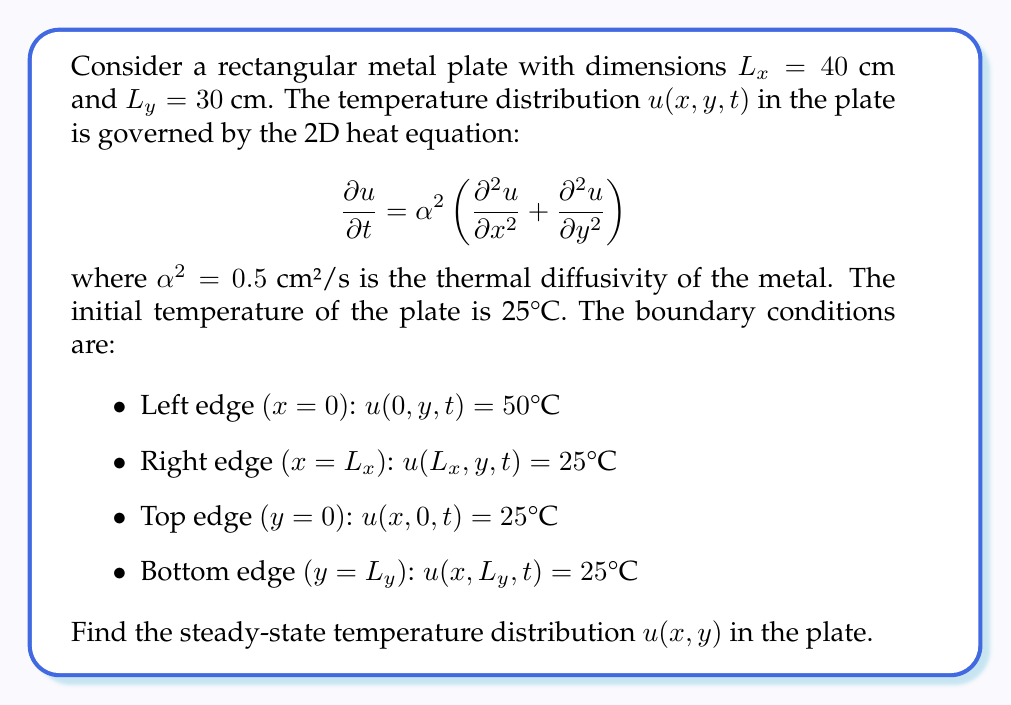Give your solution to this math problem. To solve this problem, we'll follow these steps:

1) For the steady-state solution, the temperature doesn't change with time, so $\frac{\partial u}{\partial t} = 0$. The heat equation reduces to:

   $$\frac{\partial^2 u}{\partial x^2} + \frac{\partial^2 u}{\partial y^2} = 0$$

   This is Laplace's equation in 2D.

2) Given the boundary conditions, we can use separation of variables. Let $u(x,y) = X(x)Y(y)$.

3) Substituting into Laplace's equation:

   $$Y\frac{d^2X}{dx^2} + X\frac{d^2Y}{dy^2} = 0$$

   $$\frac{1}{X}\frac{d^2X}{dx^2} = -\frac{1}{Y}\frac{d^2Y}{dy^2} = -\lambda^2$$

4) This gives us two ODEs:

   $$\frac{d^2X}{dx^2} + \lambda^2X = 0$$
   $$\frac{d^2Y}{dy^2} - \lambda^2Y = 0$$

5) The general solutions are:

   $$X(x) = A\cos(\lambda x) + B\sin(\lambda x)$$
   $$Y(y) = C\cosh(\lambda y) + D\sinh(\lambda y)$$

6) Applying the boundary conditions:

   At $x=0$: $u(0,y) = 50°C$ $\Rightarrow$ $X(0) = 50$ $\Rightarrow$ $A = 50$
   At $x=L_x$: $u(L_x,y) = 25°C$ $\Rightarrow$ $X(L_x) = 25$

   $$25 = 50\cos(\lambda L_x) + B\sin(\lambda L_x)$$

   At $y=0$ and $y=L_y$: $u(x,0) = u(x,L_y) = 25°C$ $\Rightarrow$ $Y(0) = Y(L_y) = 0$

   This is only possible if $Y(y) = 0$ for all $y$, which means the solution is independent of $y$.

7) Therefore, our solution only depends on $x$:

   $$u(x) = 50\cos(\lambda x) + B\sin(\lambda x)$$

8) Using the condition at $x=L_x$:

   $$25 = 50\cos(\lambda L_x) + B\sin(\lambda L_x)$$

   $$B = \frac{25 - 50\cos(\lambda L_x)}{\sin(\lambda L_x)}$$

9) The final solution is:

   $$u(x) = 50\cos(\lambda x) + \frac{25 - 50\cos(\lambda L_x)}{\sin(\lambda L_x)}\sin(\lambda x)$$

   where $\lambda$ can be found numerically from:

   $$25 = 50\cos(\lambda L_x)$$

   $$\lambda L_x = \arccos(0.5) \approx 1.0472$$

   $$\lambda \approx 0.2618 \text{ cm}^{-1}$$

10) Substituting this value of $\lambda$, we get the final solution:

    $$u(x) = 50\cos(0.2618x) + 43.3013\sin(0.2618x)$$

This gives the steady-state temperature distribution in the plate as a function of $x$.
Answer: The steady-state temperature distribution in the plate is given by:

$$u(x) = 50\cos(0.2618x) + 43.3013\sin(0.2618x)$$

where $x$ is the distance from the left edge of the plate in centimeters, and $u(x)$ is the temperature in °C. 